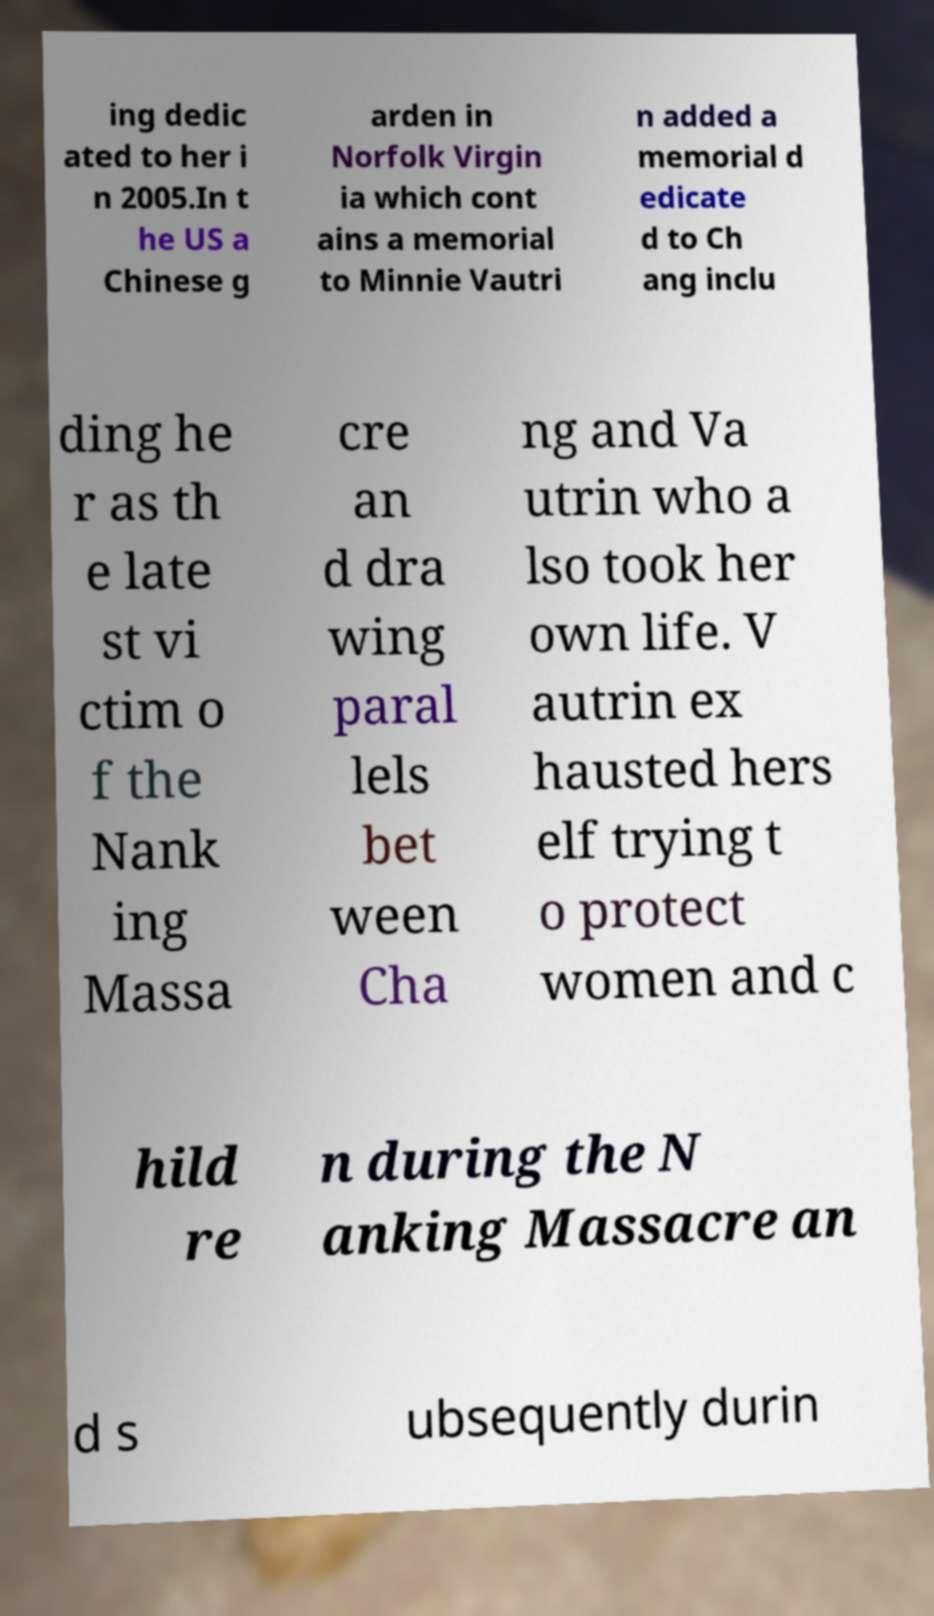Could you extract and type out the text from this image? ing dedic ated to her i n 2005.In t he US a Chinese g arden in Norfolk Virgin ia which cont ains a memorial to Minnie Vautri n added a memorial d edicate d to Ch ang inclu ding he r as th e late st vi ctim o f the Nank ing Massa cre an d dra wing paral lels bet ween Cha ng and Va utrin who a lso took her own life. V autrin ex hausted hers elf trying t o protect women and c hild re n during the N anking Massacre an d s ubsequently durin 